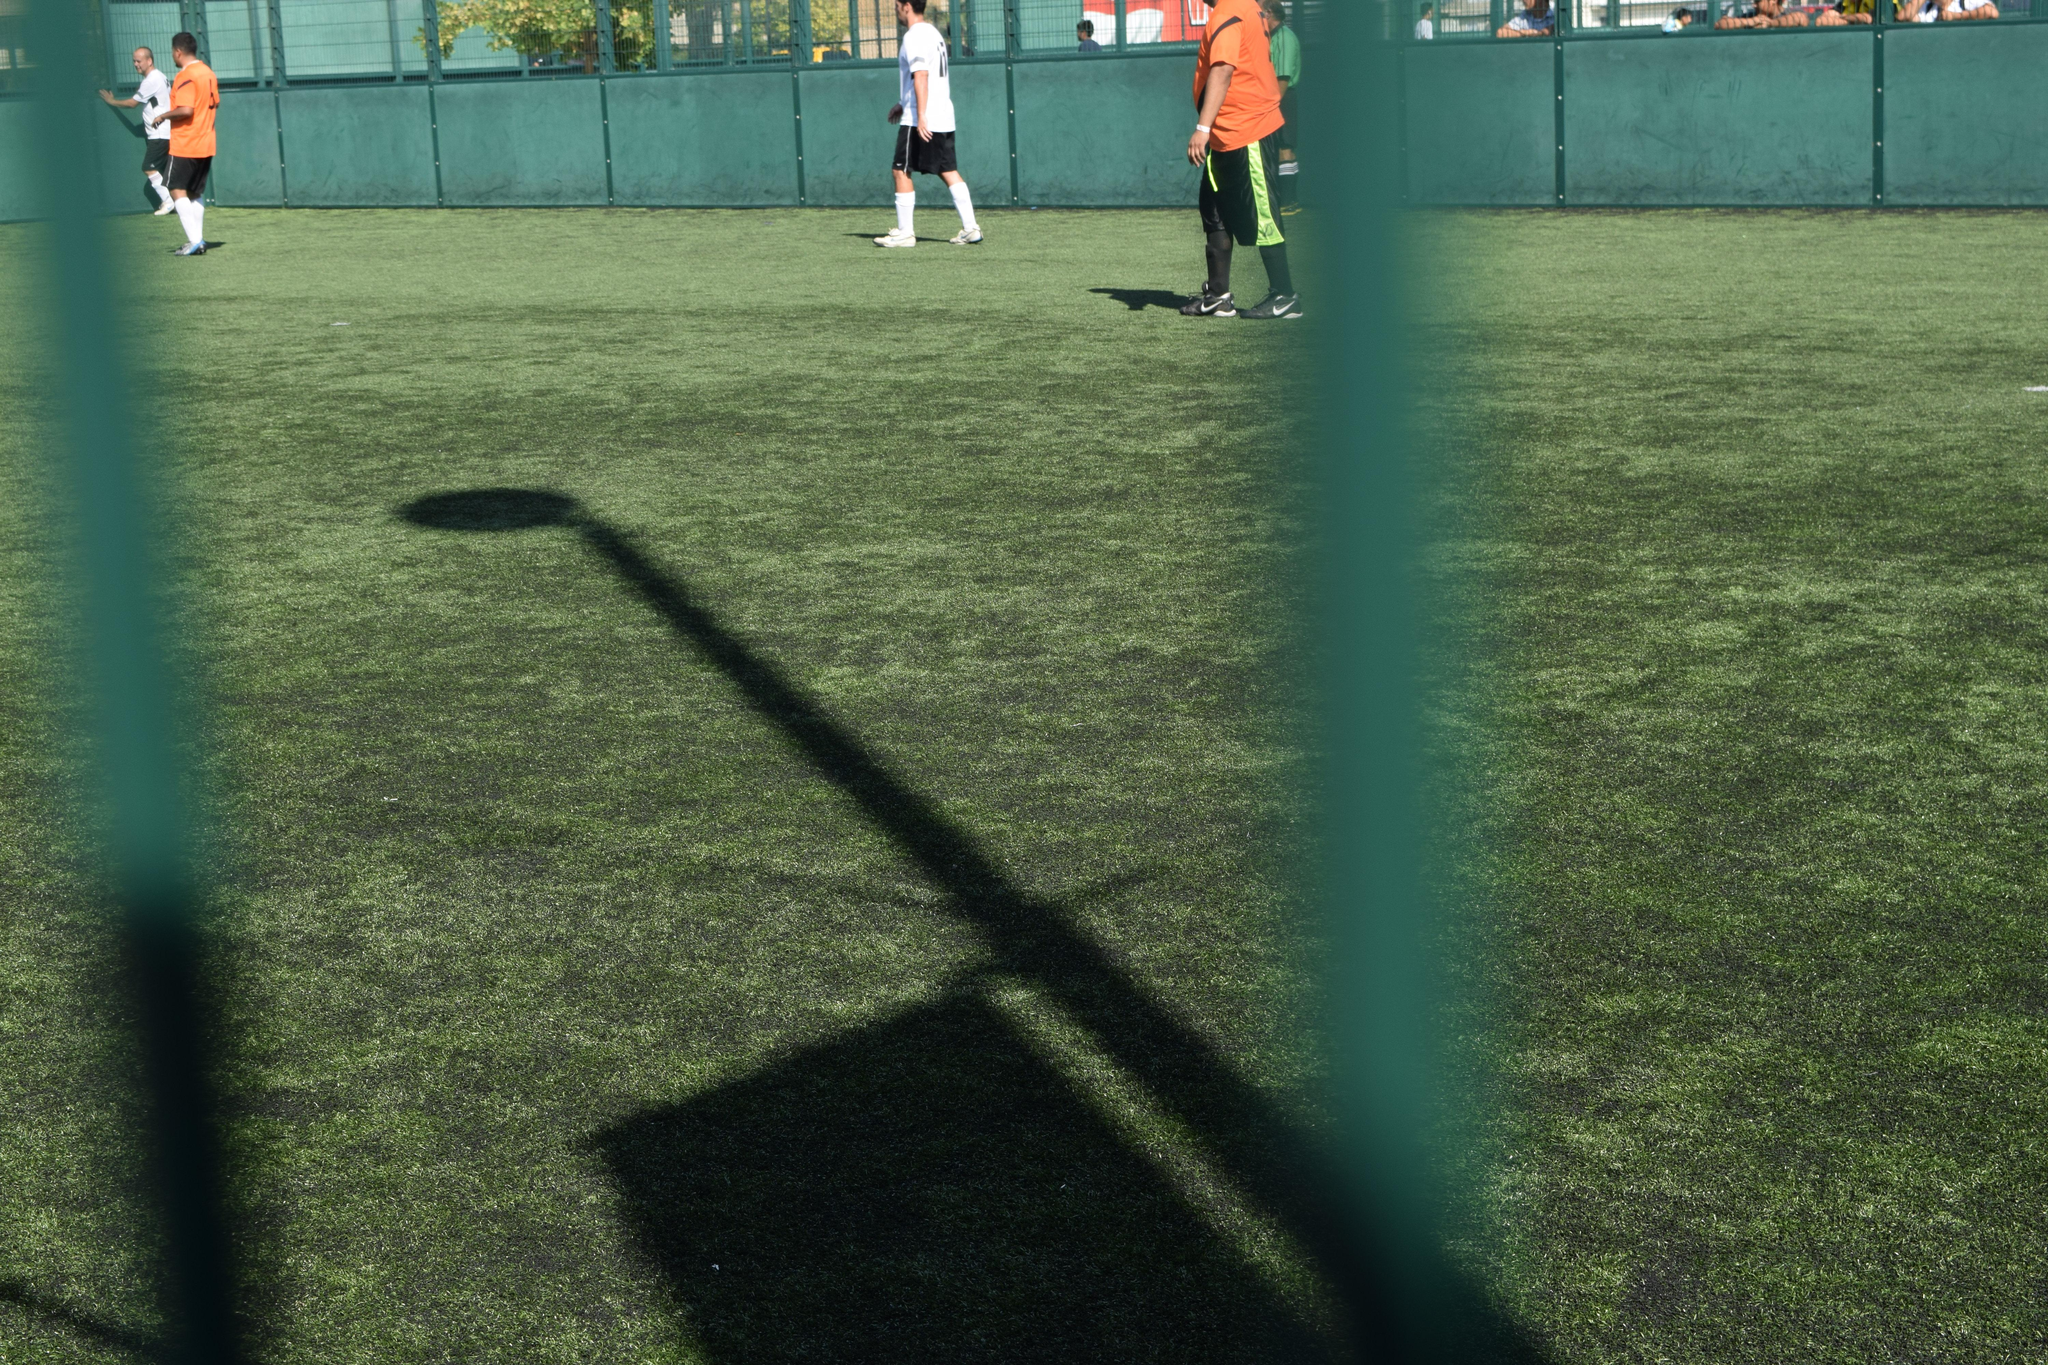What is the main subject of the image? The main subject of the image is a playground. What are the people in the image doing? The people in the image are playing in the playground. What can be seen in the background of the image? There is a wall visible in the background of the image. Can you describe anything beyond the wall in the image? Yes, there is a part of a plant visible behind the wall. How much payment is required to enter the playground in the image? There is no indication of payment or entrance fees in the image; it simply shows people playing in a playground. Can you tell me the color of the lettuce growing behind the wall in the image? There is no lettuce present in the image; only a part of a plant is visible behind the wall. 